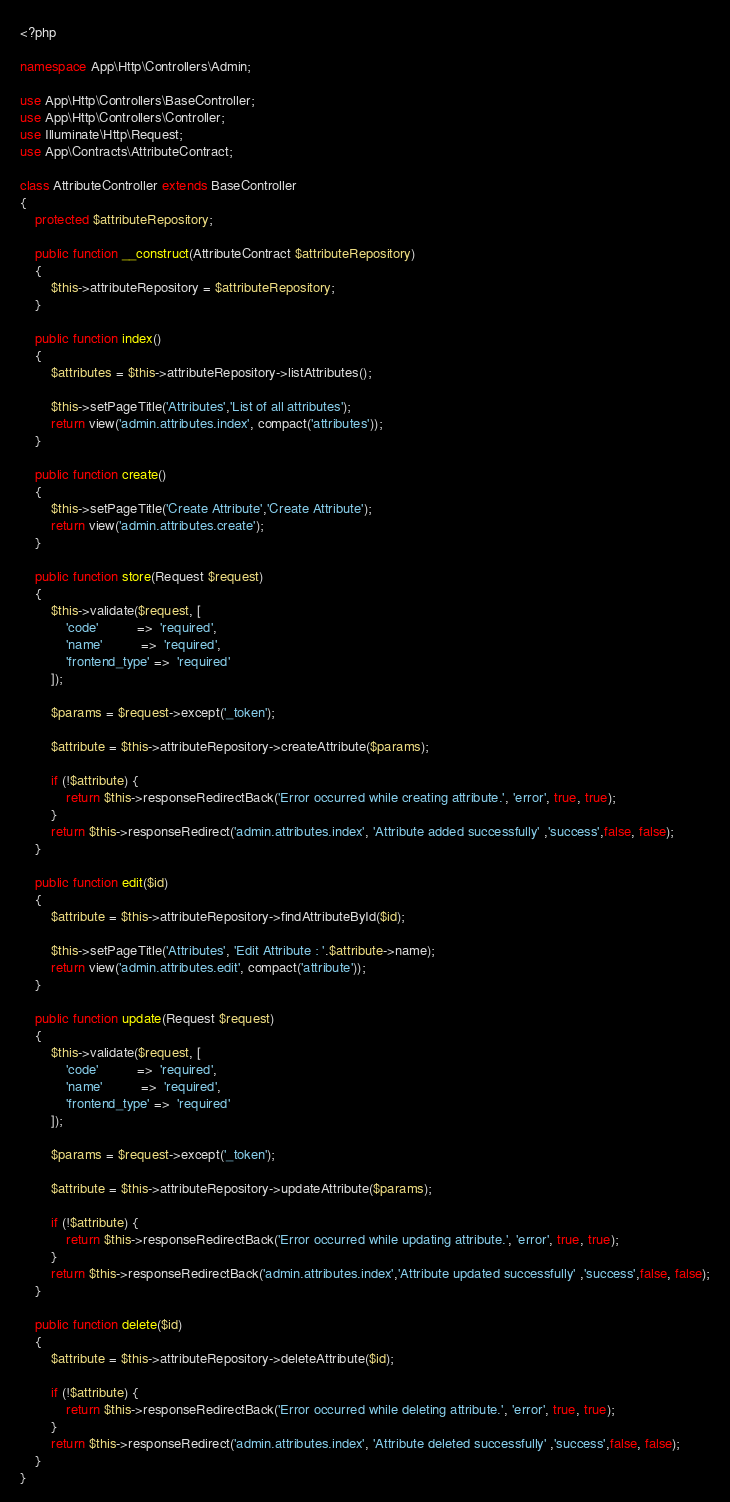<code> <loc_0><loc_0><loc_500><loc_500><_PHP_><?php

namespace App\Http\Controllers\Admin;

use App\Http\Controllers\BaseController;
use App\Http\Controllers\Controller;
use Illuminate\Http\Request;
use App\Contracts\AttributeContract;

class AttributeController extends BaseController
{
    protected $attributeRepository;

    public function __construct(AttributeContract $attributeRepository)
    {
        $this->attributeRepository = $attributeRepository;
    }

    public function index()
    {
        $attributes = $this->attributeRepository->listAttributes();

        $this->setPageTitle('Attributes','List of all attributes');
        return view('admin.attributes.index', compact('attributes'));        
    }

    public function create()
    {
        $this->setPageTitle('Create Attribute','Create Attribute');
        return view('admin.attributes.create');
    }

    public function store(Request $request)
    {
        $this->validate($request, [
            'code'          =>  'required',
            'name'          =>  'required',
            'frontend_type' =>  'required'
        ]);
    
        $params = $request->except('_token');
    
        $attribute = $this->attributeRepository->createAttribute($params);
    
        if (!$attribute) {
            return $this->responseRedirectBack('Error occurred while creating attribute.', 'error', true, true);
        }
        return $this->responseRedirect('admin.attributes.index', 'Attribute added successfully' ,'success',false, false);
    }

    public function edit($id)
    {
        $attribute = $this->attributeRepository->findAttributeById($id);

        $this->setPageTitle('Attributes', 'Edit Attribute : '.$attribute->name);
        return view('admin.attributes.edit', compact('attribute'));
    }

    public function update(Request $request)
    {
        $this->validate($request, [
            'code'          =>  'required',
            'name'          =>  'required',
            'frontend_type' =>  'required'
        ]);

        $params = $request->except('_token');

        $attribute = $this->attributeRepository->updateAttribute($params);

        if (!$attribute) {
            return $this->responseRedirectBack('Error occurred while updating attribute.', 'error', true, true);
        }
        return $this->responseRedirectBack('admin.attributes.index','Attribute updated successfully' ,'success',false, false);
    }

    public function delete($id)
    {
        $attribute = $this->attributeRepository->deleteAttribute($id);

        if (!$attribute) {
            return $this->responseRedirectBack('Error occurred while deleting attribute.', 'error', true, true);
        }
        return $this->responseRedirect('admin.attributes.index', 'Attribute deleted successfully' ,'success',false, false);
    }
}
</code> 